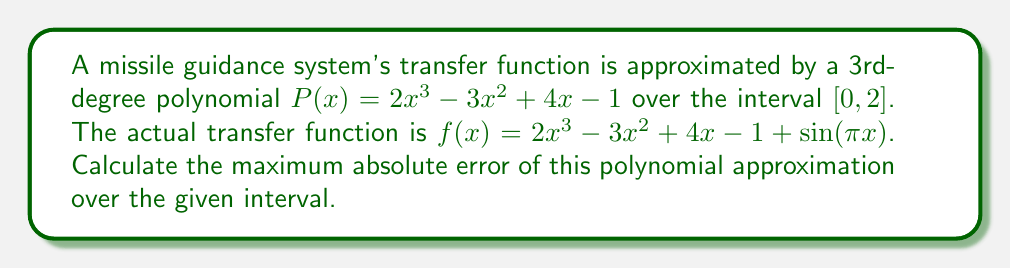Solve this math problem. To find the maximum absolute error of the polynomial approximation, we need to:

1) Define the error function $E(x) = |f(x) - P(x)|$
2) Find the maximum value of $E(x)$ over the interval $[0, 2]$

Step 1: Define the error function
$$E(x) = |f(x) - P(x)| = |\sin(πx)|$$

Step 2: Find the maximum value of $E(x)$
The sine function oscillates between -1 and 1, so $|\sin(πx)|$ will have a maximum value of 1.

To find where this maximum occurs in the interval $[0, 2]$:
- $\sin(πx) = 1$ when $πx = π/2, 5π/2, ...$
- $\sin(πx) = -1$ when $πx = 3π/2, 7π/2, ...$

In the interval $[0, 2]$, these occur at:
- $x = 0.5$ and $x = 1.5$ for $\sin(πx) = 1$
- $x = 1$ for $\sin(πx) = -1$

At all these points, $|\sin(πx)| = 1$, which is the maximum value of $E(x)$.

Therefore, the maximum absolute error of the polynomial approximation is 1.
Answer: The maximum absolute error of the polynomial approximation is 1. 